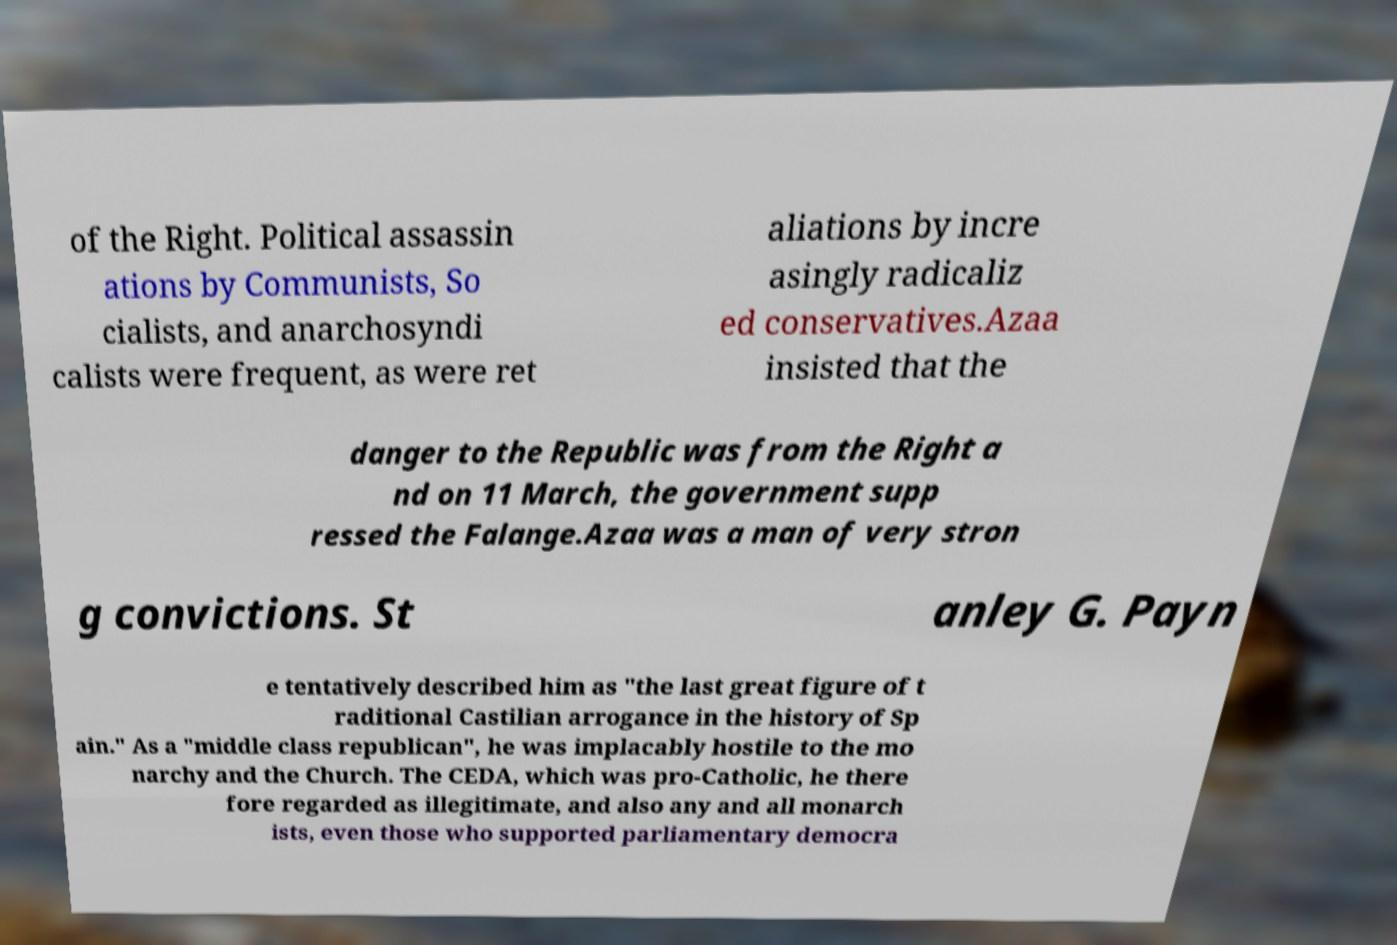Could you extract and type out the text from this image? of the Right. Political assassin ations by Communists, So cialists, and anarchosyndi calists were frequent, as were ret aliations by incre asingly radicaliz ed conservatives.Azaa insisted that the danger to the Republic was from the Right a nd on 11 March, the government supp ressed the Falange.Azaa was a man of very stron g convictions. St anley G. Payn e tentatively described him as "the last great figure of t raditional Castilian arrogance in the history of Sp ain." As a "middle class republican", he was implacably hostile to the mo narchy and the Church. The CEDA, which was pro-Catholic, he there fore regarded as illegitimate, and also any and all monarch ists, even those who supported parliamentary democra 